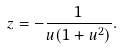<formula> <loc_0><loc_0><loc_500><loc_500>z = - \frac { 1 } { u ( 1 + u ^ { 2 } ) } .</formula> 